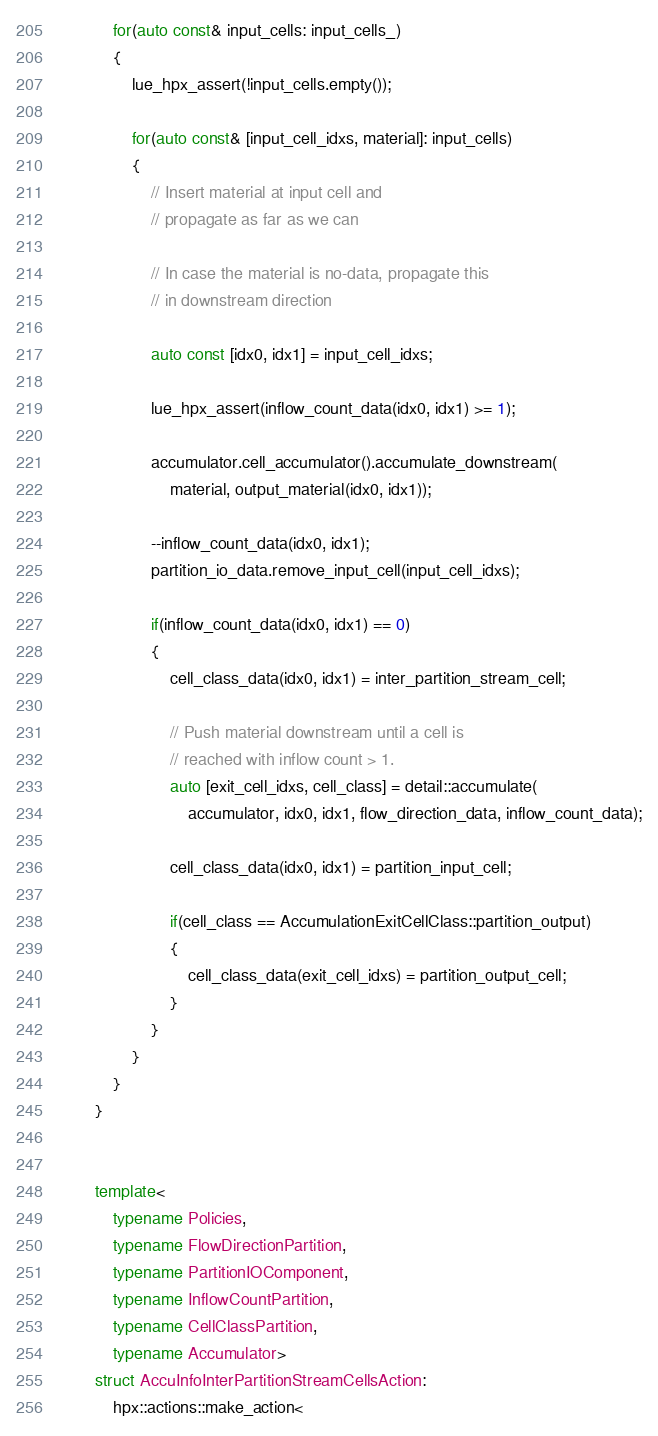Convert code to text. <code><loc_0><loc_0><loc_500><loc_500><_C++_>
            for(auto const& input_cells: input_cells_)
            {
                lue_hpx_assert(!input_cells.empty());

                for(auto const& [input_cell_idxs, material]: input_cells)
                {
                    // Insert material at input cell and
                    // propagate as far as we can

                    // In case the material is no-data, propagate this
                    // in downstream direction

                    auto const [idx0, idx1] = input_cell_idxs;

                    lue_hpx_assert(inflow_count_data(idx0, idx1) >= 1);

                    accumulator.cell_accumulator().accumulate_downstream(
                        material, output_material(idx0, idx1));

                    --inflow_count_data(idx0, idx1);
                    partition_io_data.remove_input_cell(input_cell_idxs);

                    if(inflow_count_data(idx0, idx1) == 0)
                    {
                        cell_class_data(idx0, idx1) = inter_partition_stream_cell;

                        // Push material downstream until a cell is
                        // reached with inflow count > 1.
                        auto [exit_cell_idxs, cell_class] = detail::accumulate(
                            accumulator, idx0, idx1, flow_direction_data, inflow_count_data);

                        cell_class_data(idx0, idx1) = partition_input_cell;

                        if(cell_class == AccumulationExitCellClass::partition_output)
                        {
                            cell_class_data(exit_cell_idxs) = partition_output_cell;
                        }
                    }
                }
            }
        }


        template<
            typename Policies,
            typename FlowDirectionPartition,
            typename PartitionIOComponent,
            typename InflowCountPartition,
            typename CellClassPartition,
            typename Accumulator>
        struct AccuInfoInterPartitionStreamCellsAction:
            hpx::actions::make_action<</code> 